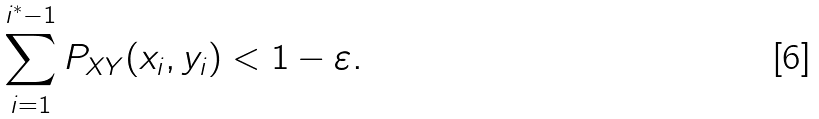Convert formula to latex. <formula><loc_0><loc_0><loc_500><loc_500>\sum _ { i = 1 } ^ { i ^ { * } - 1 } P _ { X Y } ( x _ { i } , y _ { i } ) & < 1 - \varepsilon .</formula> 